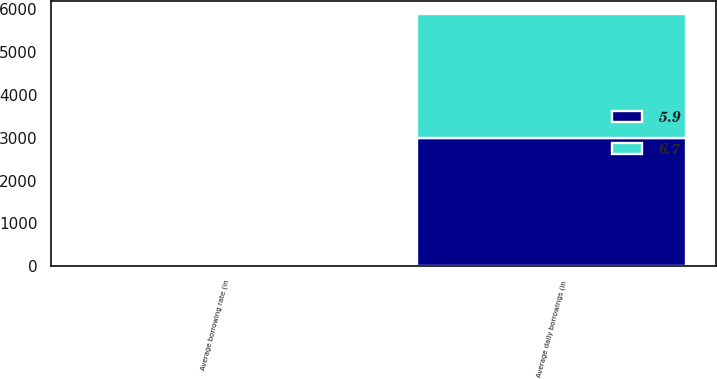<chart> <loc_0><loc_0><loc_500><loc_500><stacked_bar_chart><ecel><fcel>Average daily borrowings (in<fcel>Average borrowing rate (in<nl><fcel>5.9<fcel>2982<fcel>6.7<nl><fcel>6.7<fcel>2909<fcel>5.9<nl></chart> 